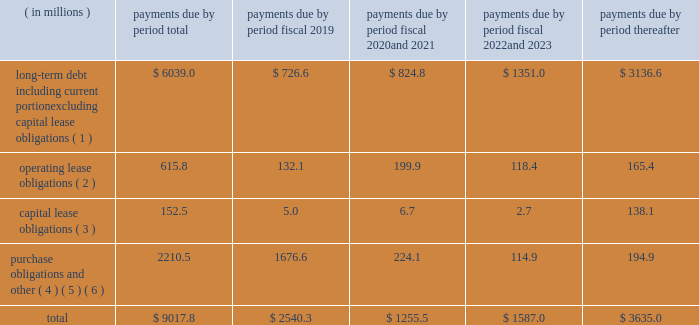Contractual obligations we summarize our enforceable and legally binding contractual obligations at september 30 , 2018 , and the effect these obligations are expected to have on our liquidity and cash flow in future periods in the table .
Certain amounts in this table are based on management fffds estimates and assumptions about these obligations , including their duration , the possibility of renewal , anticipated actions by third parties and other factors , including estimated minimum pension plan contributions and estimated benefit payments related to postretirement obligations , supplemental retirement plans and deferred compensation plans .
Because these estimates and assumptions are subjective , the enforceable and legally binding obligations we actually pay in future periods may vary from those presented in the table. .
( 1 ) includes only principal payments owed on our debt assuming that all of our long-term debt will be held to maturity , excluding scheduled payments .
We have excluded $ 205.2 million of fair value of debt step-up , deferred financing costs and unamortized bond discounts from the table to arrive at actual debt obligations .
See fffdnote 13 .
Debt fffd fffd of the notes to consolidated financial statements for information on the interest rates that apply to our various debt instruments .
( 2 ) see fffdnote 14 .
Operating leases fffd of the notes to consolidated financial statements for additional information .
( 3 ) the fair value step-up of $ 18.5 million is excluded .
See fffdnote 13 .
Debt fffd fffd capital lease and other indebtednesstt fffd of the notes to consolidated financial statements for additional information .
( 4 ) purchase obligations include agreements to purchase goods or services that are enforceable and legally binding and that specify all significant terms , including : fixed or minimum quantities to be purchased ; fixed , minimum or variable price provision ; and the approximate timing of the transaction .
Purchase obligations exclude agreements that are cancelable without penalty .
( 5 ) we have included in the table future estimated minimum pension plan contributions and estimated benefit payments related to postretirement obligations , supplemental retirement plans and deferred compensation plans .
Our estimates are based on factors , such as discount rates and expected returns on plan assets .
Future contributions are subject to changes in our underfunded status based on factors such as investment performance , discount rates , returns on plan assets and changes in legislation .
It is possible that our assumptions may change , actual market performance may vary or we may decide to contribute different amounts .
We have excluded $ 247.8 million of multiemployer pension plan withdrawal liabilities recorded as of september 30 , 2018 due to lack of definite payout terms for certain of the obligations .
See fffdnote 4 .
Retirement plans fffd multiemployer plans fffd of the notes to consolidated financial statements for additional information .
( 6 ) we have not included the following items in the table : fffd an item labeled fffdother long-term liabilities fffd reflected on our consolidated balance sheet because these liabilities do not have a definite pay-out scheme .
Fffd $ 158.4 million from the line item fffdpurchase obligations and other fffd for certain provisions of the financial accounting standards board fffds ( fffdfasb fffd ) accounting standards codification ( fffdasc fffd ) 740 , fffdincome taxes fffd associated with liabilities for uncertain tax positions due to the uncertainty as to the amount and timing of payment , if any .
In addition to the enforceable and legally binding obligations presented in the table above , we have other obligations for goods and services and raw materials entered into in the normal course of business .
These contracts , however , are subject to change based on our business decisions .
Expenditures for environmental compliance see item 1 .
Fffdbusiness fffd fffd governmental regulation fffd environmental and other matters fffd , fffdbusiness fffd fffd governmental regulation fffd cercla and other remediation costs fffd , and fffd fffdbusiness fffd fffd governmental regulation fffd climate change fffd for a discussion of our expenditures for environmental compliance. .
What would be the total amount of long-term debt if they were to include fair value of debt step-up? 
Rationale: to find the total long-term debt you need to add up all the years from the table . this should give you $ 12078 million . then , as in the question , you need to add in the fair value of debt step-up which was $ 205.2 million . this puts your total at $ 12283.2 million .
Computations: ((824.8 + 726.6) + ((6039.0 + 205.2) + (3136.6 + 1351.0)))
Answer: 12283.2. 